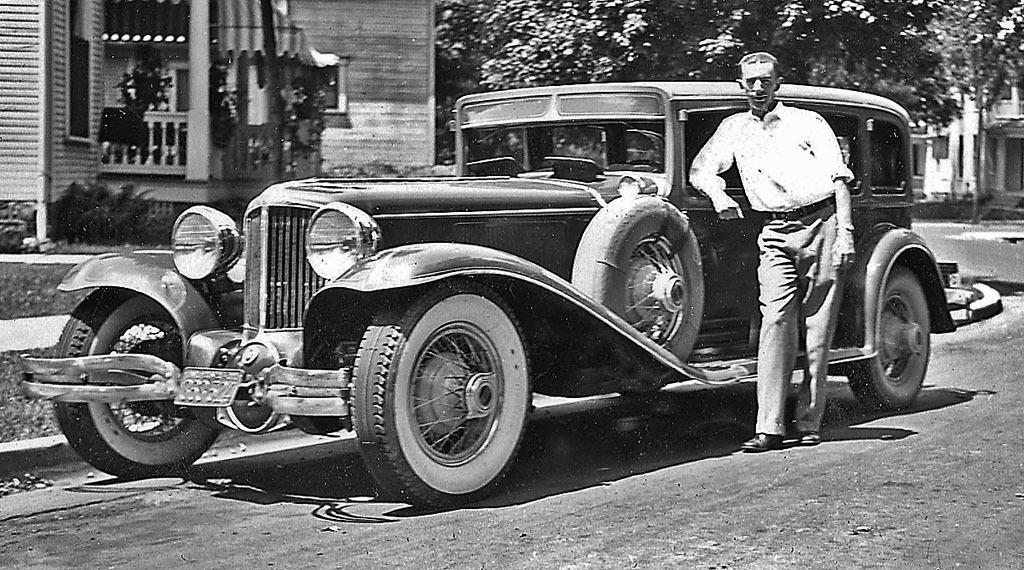What is the color scheme of the image? The image is black and white. What can be seen in the image besides the color scheme? There is a vehicle and a man standing on the road in the image. What else is present in the image? There are trees and buildings with windows in the image. Can you tell me how many nerves are visible in the image? There are no nerves present in the image; it features a vehicle, a man, trees, and buildings. What type of sofa can be seen in the image? There is no sofa present in the image. 